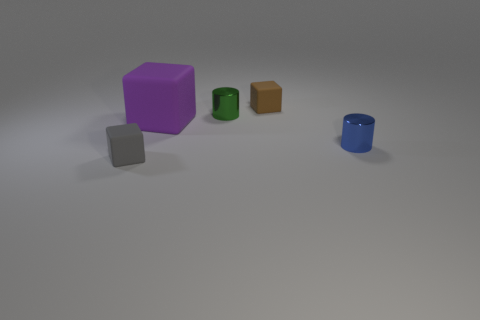How many tiny brown cylinders are there?
Your answer should be very brief. 0. How many small blocks are behind the green thing and in front of the brown thing?
Provide a short and direct response. 0. Are there any other gray objects that have the same material as the gray object?
Keep it short and to the point. No. There is a gray cube that is in front of the small rubber thing that is behind the gray cube; what is it made of?
Your response must be concise. Rubber. Is the number of shiny things that are behind the big purple thing the same as the number of matte objects in front of the small gray block?
Provide a short and direct response. No. Does the purple object have the same shape as the small brown thing?
Provide a succinct answer. Yes. The small thing that is both in front of the purple matte thing and left of the tiny blue metallic object is made of what material?
Keep it short and to the point. Rubber. How many other big purple rubber things are the same shape as the large rubber object?
Provide a short and direct response. 0. How big is the blue cylinder behind the thing that is in front of the metallic object on the right side of the green metallic thing?
Offer a terse response. Small. Is the number of green objects that are right of the tiny blue shiny object greater than the number of purple rubber objects?
Offer a terse response. No. 